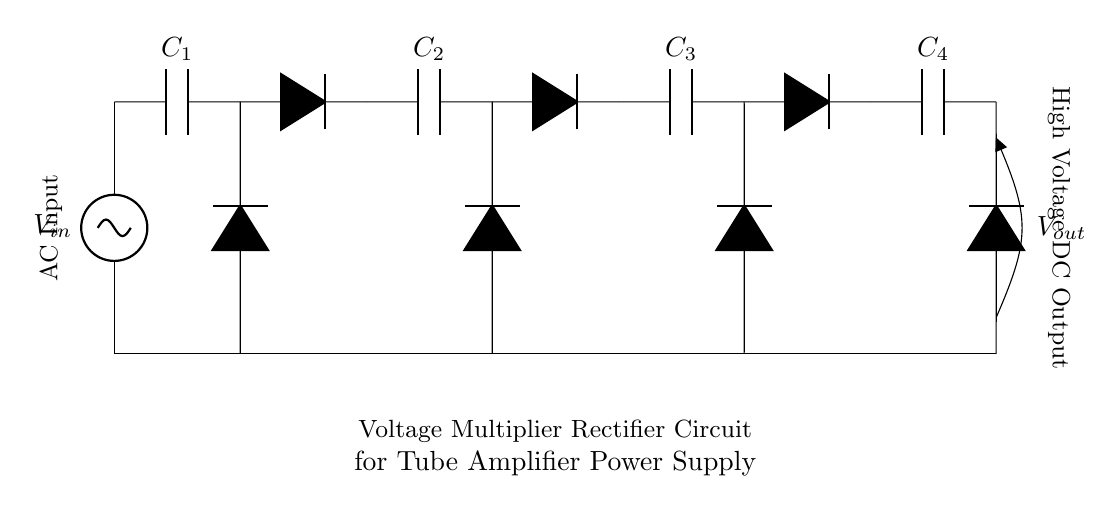What is the input voltage type in this circuit? The circuit uses an alternating current (AC) source, indicated by the label on the input connection.
Answer: AC How many capacitors are present in the circuit? There are four capacitors labeled C1, C2, C3, and C4, visible in the circuit diagram connected in series.
Answer: 4 What is the function of the diodes in this rectifier circuit? The diodes function as rectifiers, allowing current to flow in one direction only, thereby converting AC to DC.
Answer: Rectification What is the output voltage type of the circuit? The output voltage is direct current (DC), as shown by the label on the output connection indicating the nature of the voltage after rectification.
Answer: DC Which component's primary role is to store electrical energy? The capacitors serve the primary role of storing electrical energy, charging during the positive half-cycle of AC and releasing energy in the negative half-cycle.
Answer: Capacitors How do the capacitors increase the output voltage in this circuit? The capacitors charge during the peak of the AC input and discharge in a way that they stack their voltages, which can result in a higher voltage output than the AC input, hence functioning as a voltage multiplier.
Answer: Voltage multiplication What does the output label indicate about this circuit? The label indicates that the output is a high voltage DC supply, which is suitable for powering vacuum tube amplifiers commonly used in audio applications.
Answer: High Voltage DC Output 